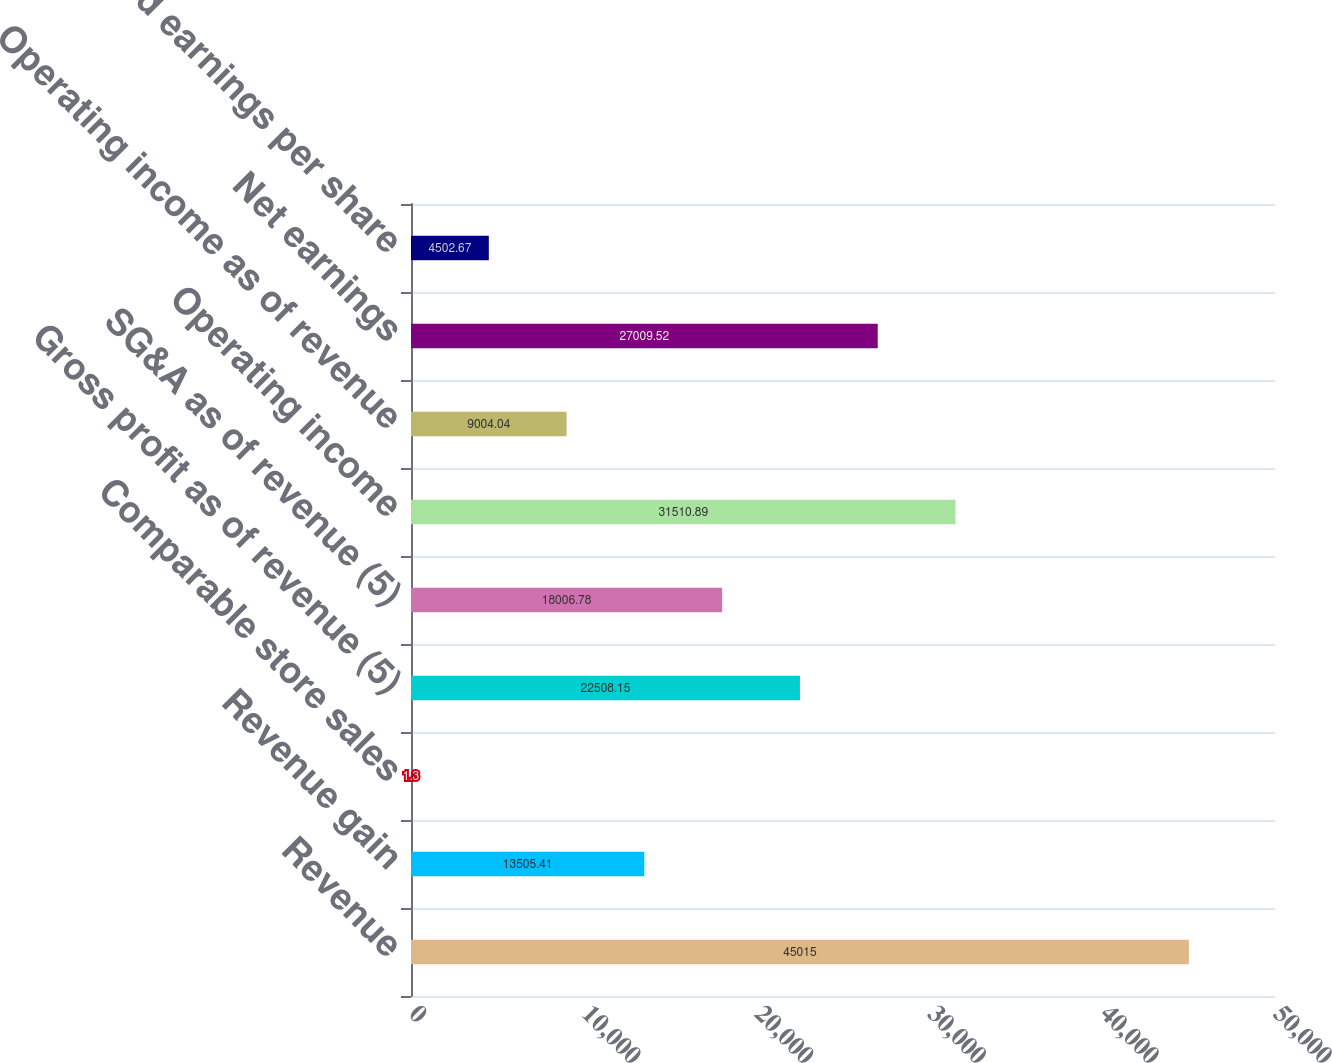Convert chart. <chart><loc_0><loc_0><loc_500><loc_500><bar_chart><fcel>Revenue<fcel>Revenue gain<fcel>Comparable store sales<fcel>Gross profit as of revenue (5)<fcel>SG&A as of revenue (5)<fcel>Operating income<fcel>Operating income as of revenue<fcel>Net earnings<fcel>Diluted earnings per share<nl><fcel>45015<fcel>13505.4<fcel>1.3<fcel>22508.2<fcel>18006.8<fcel>31510.9<fcel>9004.04<fcel>27009.5<fcel>4502.67<nl></chart> 